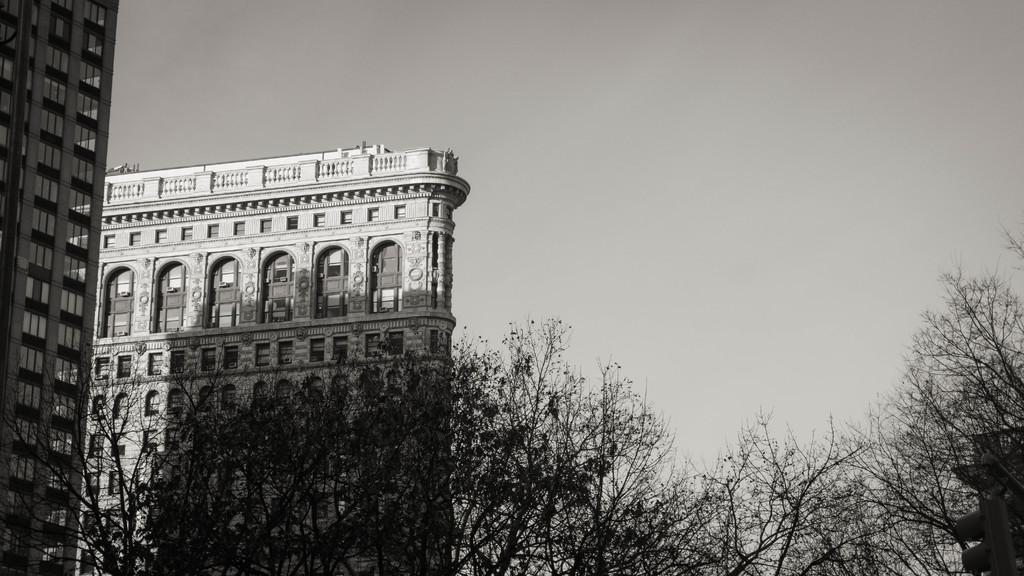What type of vegetation can be seen in the image? There are trees in the image. What structures are located on the left side of the image? There are large buildings on the left side of the image. What is visible in the background of the image? The sky is visible in the background of the image. Can you see any brass instruments being played by a monkey in the image? There is no monkey or brass instruments present in the image. How many hens are visible in the image? There are no hens present in the image. 